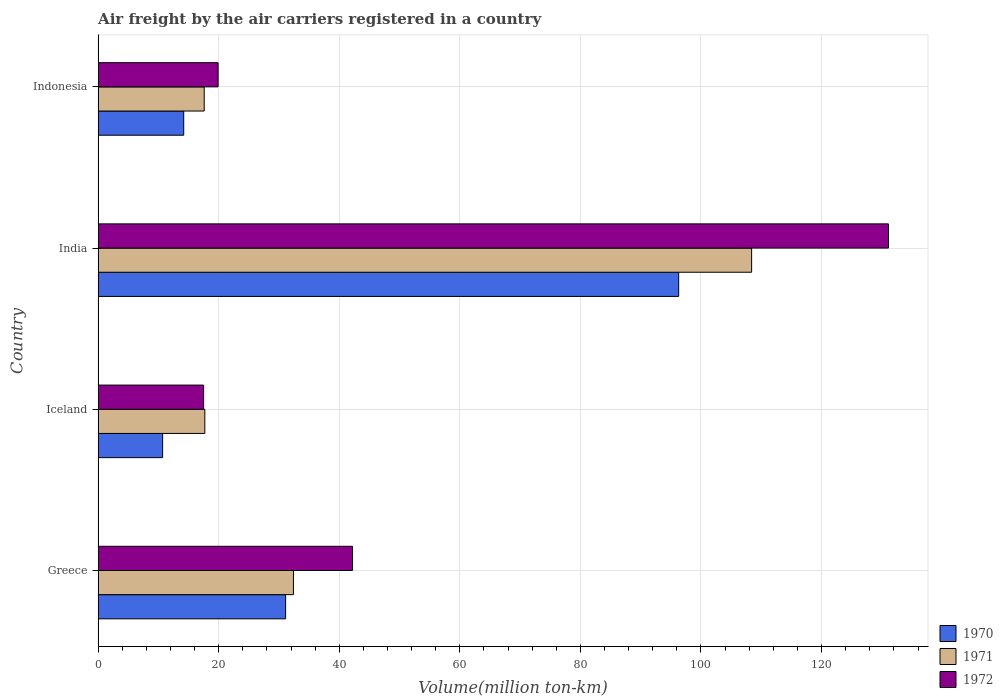How many groups of bars are there?
Your response must be concise. 4. Are the number of bars per tick equal to the number of legend labels?
Give a very brief answer. Yes. How many bars are there on the 2nd tick from the top?
Keep it short and to the point. 3. What is the label of the 3rd group of bars from the top?
Provide a succinct answer. Iceland. In how many cases, is the number of bars for a given country not equal to the number of legend labels?
Your response must be concise. 0. What is the volume of the air carriers in 1970 in Indonesia?
Your answer should be very brief. 14.2. Across all countries, what is the maximum volume of the air carriers in 1971?
Offer a very short reply. 108.4. What is the total volume of the air carriers in 1970 in the graph?
Give a very brief answer. 152.3. What is the difference between the volume of the air carriers in 1972 in Greece and that in Iceland?
Ensure brevity in your answer.  24.7. What is the difference between the volume of the air carriers in 1971 in India and the volume of the air carriers in 1970 in Iceland?
Provide a succinct answer. 97.7. What is the average volume of the air carriers in 1972 per country?
Your answer should be very brief. 52.68. What is the difference between the volume of the air carriers in 1971 and volume of the air carriers in 1972 in Iceland?
Offer a very short reply. 0.2. In how many countries, is the volume of the air carriers in 1972 greater than 4 million ton-km?
Keep it short and to the point. 4. What is the ratio of the volume of the air carriers in 1970 in Greece to that in Indonesia?
Your response must be concise. 2.19. Is the difference between the volume of the air carriers in 1971 in Greece and Iceland greater than the difference between the volume of the air carriers in 1972 in Greece and Iceland?
Your answer should be very brief. No. What is the difference between the highest and the second highest volume of the air carriers in 1972?
Your response must be concise. 88.9. What is the difference between the highest and the lowest volume of the air carriers in 1971?
Make the answer very short. 90.8. Is the sum of the volume of the air carriers in 1971 in India and Indonesia greater than the maximum volume of the air carriers in 1972 across all countries?
Offer a terse response. No. Is it the case that in every country, the sum of the volume of the air carriers in 1970 and volume of the air carriers in 1972 is greater than the volume of the air carriers in 1971?
Your answer should be very brief. Yes. How many bars are there?
Give a very brief answer. 12. Are all the bars in the graph horizontal?
Your response must be concise. Yes. How many countries are there in the graph?
Offer a terse response. 4. Does the graph contain grids?
Offer a very short reply. Yes. What is the title of the graph?
Provide a short and direct response. Air freight by the air carriers registered in a country. What is the label or title of the X-axis?
Offer a very short reply. Volume(million ton-km). What is the label or title of the Y-axis?
Your answer should be compact. Country. What is the Volume(million ton-km) in 1970 in Greece?
Your answer should be very brief. 31.1. What is the Volume(million ton-km) in 1971 in Greece?
Ensure brevity in your answer.  32.4. What is the Volume(million ton-km) of 1972 in Greece?
Provide a short and direct response. 42.2. What is the Volume(million ton-km) in 1970 in Iceland?
Provide a short and direct response. 10.7. What is the Volume(million ton-km) in 1971 in Iceland?
Your answer should be very brief. 17.7. What is the Volume(million ton-km) in 1970 in India?
Offer a terse response. 96.3. What is the Volume(million ton-km) in 1971 in India?
Offer a very short reply. 108.4. What is the Volume(million ton-km) in 1972 in India?
Offer a terse response. 131.1. What is the Volume(million ton-km) of 1970 in Indonesia?
Provide a short and direct response. 14.2. What is the Volume(million ton-km) of 1971 in Indonesia?
Offer a very short reply. 17.6. What is the Volume(million ton-km) in 1972 in Indonesia?
Keep it short and to the point. 19.9. Across all countries, what is the maximum Volume(million ton-km) of 1970?
Offer a very short reply. 96.3. Across all countries, what is the maximum Volume(million ton-km) of 1971?
Keep it short and to the point. 108.4. Across all countries, what is the maximum Volume(million ton-km) in 1972?
Offer a terse response. 131.1. Across all countries, what is the minimum Volume(million ton-km) of 1970?
Keep it short and to the point. 10.7. Across all countries, what is the minimum Volume(million ton-km) in 1971?
Your response must be concise. 17.6. Across all countries, what is the minimum Volume(million ton-km) of 1972?
Keep it short and to the point. 17.5. What is the total Volume(million ton-km) of 1970 in the graph?
Your answer should be very brief. 152.3. What is the total Volume(million ton-km) in 1971 in the graph?
Make the answer very short. 176.1. What is the total Volume(million ton-km) of 1972 in the graph?
Ensure brevity in your answer.  210.7. What is the difference between the Volume(million ton-km) in 1970 in Greece and that in Iceland?
Your answer should be very brief. 20.4. What is the difference between the Volume(million ton-km) in 1971 in Greece and that in Iceland?
Give a very brief answer. 14.7. What is the difference between the Volume(million ton-km) of 1972 in Greece and that in Iceland?
Make the answer very short. 24.7. What is the difference between the Volume(million ton-km) in 1970 in Greece and that in India?
Keep it short and to the point. -65.2. What is the difference between the Volume(million ton-km) in 1971 in Greece and that in India?
Ensure brevity in your answer.  -76. What is the difference between the Volume(million ton-km) of 1972 in Greece and that in India?
Provide a short and direct response. -88.9. What is the difference between the Volume(million ton-km) in 1970 in Greece and that in Indonesia?
Provide a short and direct response. 16.9. What is the difference between the Volume(million ton-km) of 1971 in Greece and that in Indonesia?
Give a very brief answer. 14.8. What is the difference between the Volume(million ton-km) of 1972 in Greece and that in Indonesia?
Keep it short and to the point. 22.3. What is the difference between the Volume(million ton-km) of 1970 in Iceland and that in India?
Keep it short and to the point. -85.6. What is the difference between the Volume(million ton-km) in 1971 in Iceland and that in India?
Keep it short and to the point. -90.7. What is the difference between the Volume(million ton-km) of 1972 in Iceland and that in India?
Offer a very short reply. -113.6. What is the difference between the Volume(million ton-km) of 1971 in Iceland and that in Indonesia?
Offer a very short reply. 0.1. What is the difference between the Volume(million ton-km) in 1972 in Iceland and that in Indonesia?
Ensure brevity in your answer.  -2.4. What is the difference between the Volume(million ton-km) of 1970 in India and that in Indonesia?
Your answer should be very brief. 82.1. What is the difference between the Volume(million ton-km) of 1971 in India and that in Indonesia?
Offer a very short reply. 90.8. What is the difference between the Volume(million ton-km) in 1972 in India and that in Indonesia?
Make the answer very short. 111.2. What is the difference between the Volume(million ton-km) in 1970 in Greece and the Volume(million ton-km) in 1971 in Iceland?
Give a very brief answer. 13.4. What is the difference between the Volume(million ton-km) of 1970 in Greece and the Volume(million ton-km) of 1972 in Iceland?
Provide a succinct answer. 13.6. What is the difference between the Volume(million ton-km) in 1970 in Greece and the Volume(million ton-km) in 1971 in India?
Give a very brief answer. -77.3. What is the difference between the Volume(million ton-km) of 1970 in Greece and the Volume(million ton-km) of 1972 in India?
Keep it short and to the point. -100. What is the difference between the Volume(million ton-km) of 1971 in Greece and the Volume(million ton-km) of 1972 in India?
Your response must be concise. -98.7. What is the difference between the Volume(million ton-km) of 1970 in Greece and the Volume(million ton-km) of 1972 in Indonesia?
Your response must be concise. 11.2. What is the difference between the Volume(million ton-km) of 1970 in Iceland and the Volume(million ton-km) of 1971 in India?
Keep it short and to the point. -97.7. What is the difference between the Volume(million ton-km) of 1970 in Iceland and the Volume(million ton-km) of 1972 in India?
Offer a very short reply. -120.4. What is the difference between the Volume(million ton-km) of 1971 in Iceland and the Volume(million ton-km) of 1972 in India?
Keep it short and to the point. -113.4. What is the difference between the Volume(million ton-km) in 1970 in Iceland and the Volume(million ton-km) in 1972 in Indonesia?
Provide a succinct answer. -9.2. What is the difference between the Volume(million ton-km) in 1970 in India and the Volume(million ton-km) in 1971 in Indonesia?
Offer a terse response. 78.7. What is the difference between the Volume(million ton-km) in 1970 in India and the Volume(million ton-km) in 1972 in Indonesia?
Your answer should be very brief. 76.4. What is the difference between the Volume(million ton-km) in 1971 in India and the Volume(million ton-km) in 1972 in Indonesia?
Provide a short and direct response. 88.5. What is the average Volume(million ton-km) in 1970 per country?
Provide a succinct answer. 38.08. What is the average Volume(million ton-km) of 1971 per country?
Give a very brief answer. 44.02. What is the average Volume(million ton-km) in 1972 per country?
Offer a terse response. 52.67. What is the difference between the Volume(million ton-km) of 1970 and Volume(million ton-km) of 1972 in Greece?
Your answer should be compact. -11.1. What is the difference between the Volume(million ton-km) in 1970 and Volume(million ton-km) in 1972 in India?
Make the answer very short. -34.8. What is the difference between the Volume(million ton-km) in 1971 and Volume(million ton-km) in 1972 in India?
Offer a very short reply. -22.7. What is the difference between the Volume(million ton-km) of 1970 and Volume(million ton-km) of 1971 in Indonesia?
Offer a terse response. -3.4. What is the ratio of the Volume(million ton-km) in 1970 in Greece to that in Iceland?
Your answer should be compact. 2.91. What is the ratio of the Volume(million ton-km) of 1971 in Greece to that in Iceland?
Your answer should be very brief. 1.83. What is the ratio of the Volume(million ton-km) in 1972 in Greece to that in Iceland?
Give a very brief answer. 2.41. What is the ratio of the Volume(million ton-km) in 1970 in Greece to that in India?
Make the answer very short. 0.32. What is the ratio of the Volume(million ton-km) of 1971 in Greece to that in India?
Provide a succinct answer. 0.3. What is the ratio of the Volume(million ton-km) in 1972 in Greece to that in India?
Make the answer very short. 0.32. What is the ratio of the Volume(million ton-km) of 1970 in Greece to that in Indonesia?
Your response must be concise. 2.19. What is the ratio of the Volume(million ton-km) of 1971 in Greece to that in Indonesia?
Ensure brevity in your answer.  1.84. What is the ratio of the Volume(million ton-km) in 1972 in Greece to that in Indonesia?
Your answer should be very brief. 2.12. What is the ratio of the Volume(million ton-km) in 1971 in Iceland to that in India?
Offer a very short reply. 0.16. What is the ratio of the Volume(million ton-km) of 1972 in Iceland to that in India?
Make the answer very short. 0.13. What is the ratio of the Volume(million ton-km) in 1970 in Iceland to that in Indonesia?
Keep it short and to the point. 0.75. What is the ratio of the Volume(million ton-km) of 1971 in Iceland to that in Indonesia?
Your answer should be compact. 1.01. What is the ratio of the Volume(million ton-km) in 1972 in Iceland to that in Indonesia?
Offer a very short reply. 0.88. What is the ratio of the Volume(million ton-km) of 1970 in India to that in Indonesia?
Provide a short and direct response. 6.78. What is the ratio of the Volume(million ton-km) in 1971 in India to that in Indonesia?
Your answer should be compact. 6.16. What is the ratio of the Volume(million ton-km) in 1972 in India to that in Indonesia?
Your response must be concise. 6.59. What is the difference between the highest and the second highest Volume(million ton-km) of 1970?
Give a very brief answer. 65.2. What is the difference between the highest and the second highest Volume(million ton-km) in 1972?
Offer a very short reply. 88.9. What is the difference between the highest and the lowest Volume(million ton-km) in 1970?
Offer a very short reply. 85.6. What is the difference between the highest and the lowest Volume(million ton-km) of 1971?
Provide a succinct answer. 90.8. What is the difference between the highest and the lowest Volume(million ton-km) in 1972?
Your answer should be compact. 113.6. 